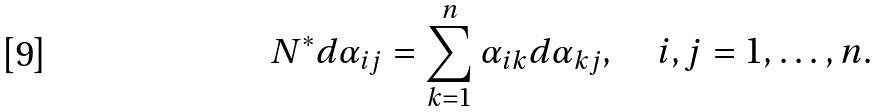Convert formula to latex. <formula><loc_0><loc_0><loc_500><loc_500>N ^ { \ast } d \alpha _ { i j } = \sum _ { k = 1 } ^ { n } \alpha _ { i k } d \alpha _ { k j } , \quad i , j = 1 , \dots , n .</formula> 